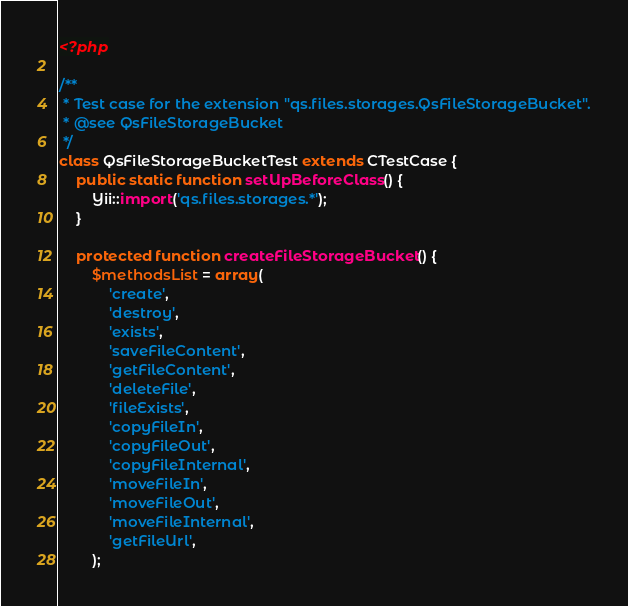<code> <loc_0><loc_0><loc_500><loc_500><_PHP_><?php

/**
 * Test case for the extension "qs.files.storages.QsFileStorageBucket".
 * @see QsFileStorageBucket
 */
class QsFileStorageBucketTest extends CTestCase {
	public static function setUpBeforeClass() {
		Yii::import('qs.files.storages.*');
	}

	protected function createFileStorageBucket() {
		$methodsList = array(
			'create',
			'destroy',
			'exists',
			'saveFileContent',
			'getFileContent',
			'deleteFile',
			'fileExists',
			'copyFileIn',
			'copyFileOut',
			'copyFileInternal',
			'moveFileIn',
			'moveFileOut',
			'moveFileInternal',
			'getFileUrl',
		);</code> 